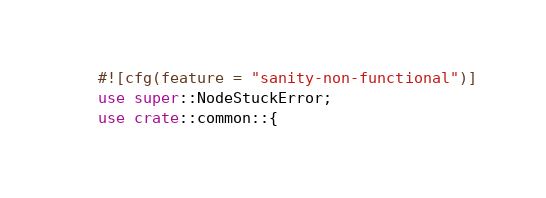Convert code to text. <code><loc_0><loc_0><loc_500><loc_500><_Rust_>#![cfg(feature = "sanity-non-functional")]
use super::NodeStuckError;
use crate::common::{</code> 